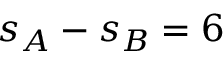<formula> <loc_0><loc_0><loc_500><loc_500>s _ { A } - s _ { B } = 6</formula> 